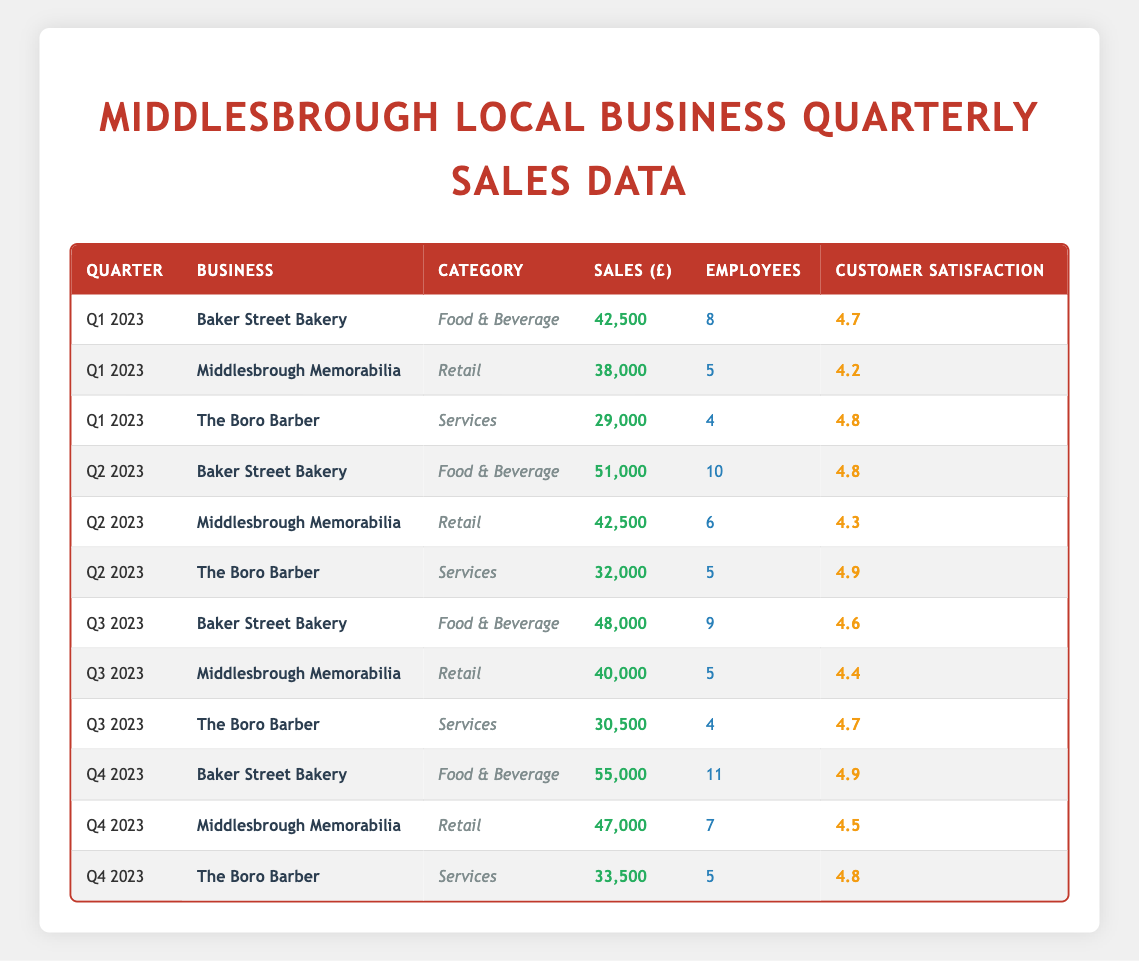What are the total sales for Baker Street Bakery across all quarters? Adding the sales for Baker Street Bakery from all quarters: Q1 (42,500) + Q2 (51,000) + Q3 (48,000) + Q4 (55,000) = 196,500.
Answer: 196,500 Which quarter had the highest sales for Middlesbrough Memorabilia? Looking at the sales figures for Middlesbrough Memorabilia, Q1 (38,000), Q2 (42,500), Q3 (40,000), and Q4 (47,000). The highest is in Q4 with 47,000.
Answer: Q4 2023 Did The Boro Barber have higher sales in Q3 than in Q1? The Boro Barber's sales were Q1 (29,000) and Q3 (30,500). Q3 is higher than Q1.
Answer: Yes What is the average customer satisfaction score for the three businesses in Q2 2023? The customer satisfaction scores are: Baker Street Bakery (4.8), Middlesbrough Memorabilia (4.3), The Boro Barber (4.9). Their average is (4.8 + 4.3 + 4.9) / 3 = 4.67.
Answer: 4.67 Which business has the highest customer satisfaction and what is the score? The customer satisfaction scores are: Baker Street Bakery (4.7, 4.8, 4.6, 4.9), Middlesbrough Memorabilia (4.2, 4.3, 4.4, 4.5), The Boro Barber (4.8, 4.9, 4.7, 4.8). The highest score is 4.9 from Baker Street Bakery in Q4.
Answer: Baker Street Bakery, 4.9 How many employees did The Boro Barber have in Q1 2023? Referring to the data for The Boro Barber in Q1 2023, it shows that there were 4 employees.
Answer: 4 Which quarter had the least sales overall? Summing the sales for each quarter: Q1 (42,500 + 38,000 + 29,000 = 109,500), Q2 (51,000 + 42,500 + 32,000 = 125,500), Q3 (48,000 + 40,000 + 30,500 = 118,500), Q4 (55,000 + 47,000 + 33,500 = 135,500). The least is Q1 at 109,500.
Answer: Q1 2023 What is the difference in sales between the highest and lowest quarters for Baker Street Bakery? The highest sales are Q4 (55,000) and the lowest are Q1 (42,500). The difference is 55,000 - 42,500 = 12,500.
Answer: 12,500 Was there an increase in sales for Middlesbrough Memorabilia from Q2 to Q3? Comparing the sales figures for Middlesbrough Memorabilia: Q2 (42,500) and Q3 (40,000). Since 40,000 is less than 42,500, there was a decrease.
Answer: No 